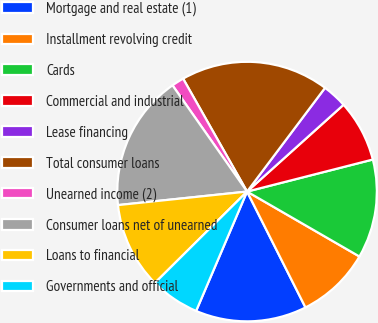<chart> <loc_0><loc_0><loc_500><loc_500><pie_chart><fcel>Mortgage and real estate (1)<fcel>Installment revolving credit<fcel>Cards<fcel>Commercial and industrial<fcel>Lease financing<fcel>Total consumer loans<fcel>Unearned income (2)<fcel>Consumer loans net of unearned<fcel>Loans to financial<fcel>Governments and official<nl><fcel>13.85%<fcel>9.23%<fcel>12.31%<fcel>7.69%<fcel>3.08%<fcel>18.46%<fcel>1.54%<fcel>16.92%<fcel>10.77%<fcel>6.15%<nl></chart> 